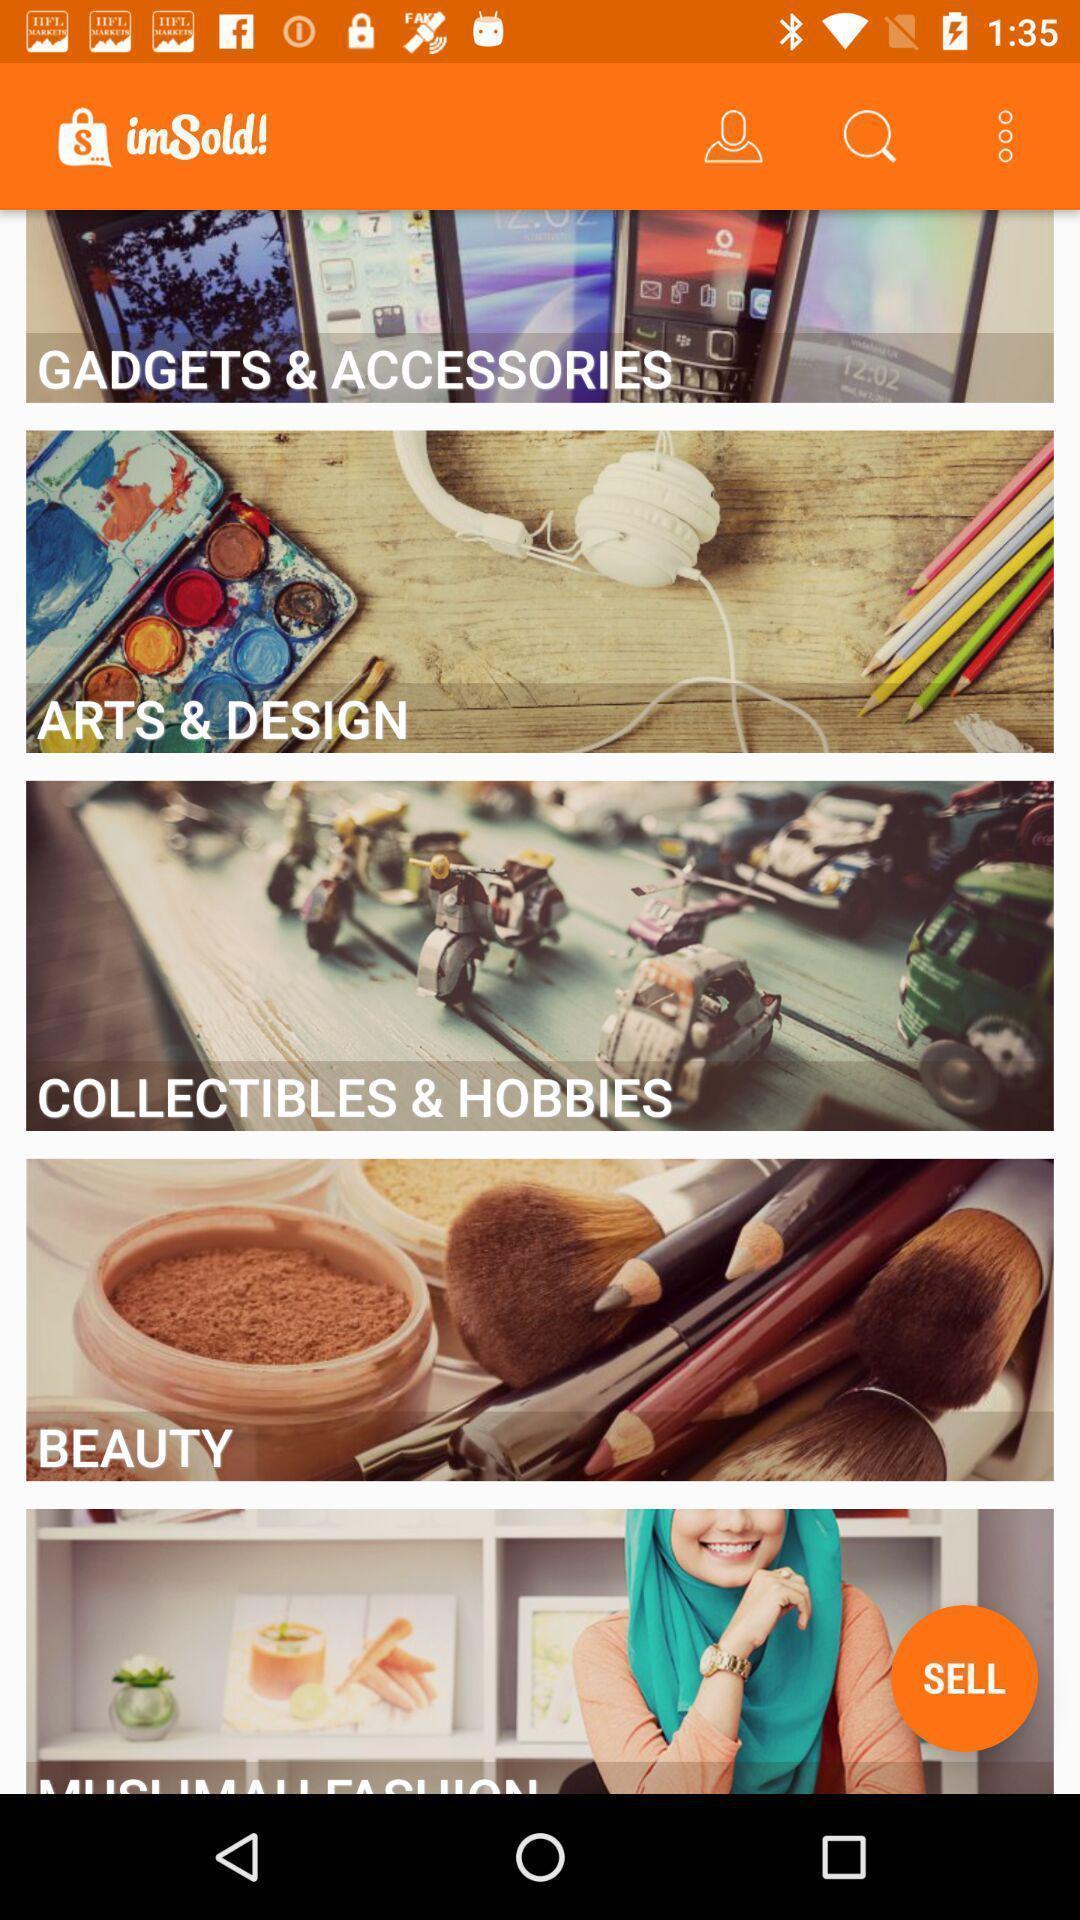What details can you identify in this image? Screen displaying multiple category options with names. 